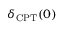<formula> <loc_0><loc_0><loc_500><loc_500>\delta _ { C P T } ( 0 )</formula> 